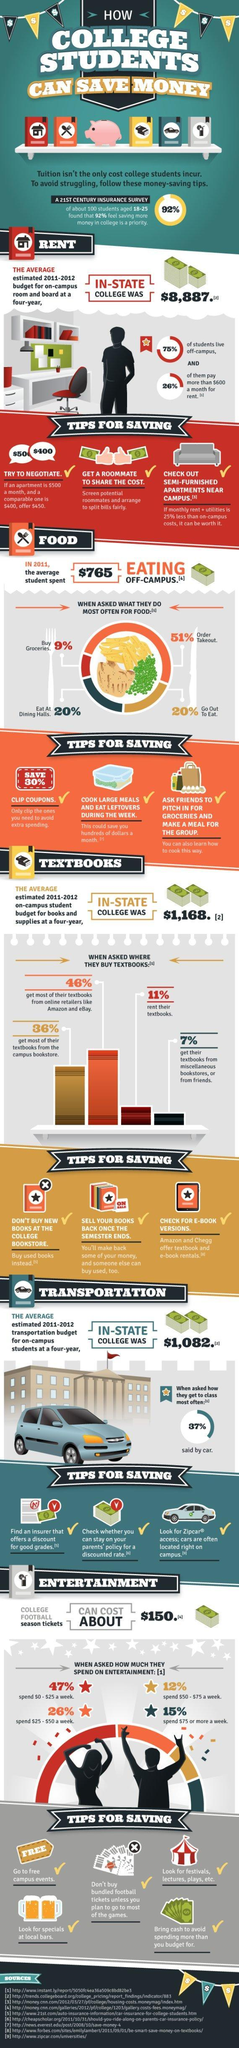What percentage of students neither buy their books from the campus store nor online?
Answer the question with a short phrase. 82% What percentage of college students Order takeout or go out to eat? 71% 